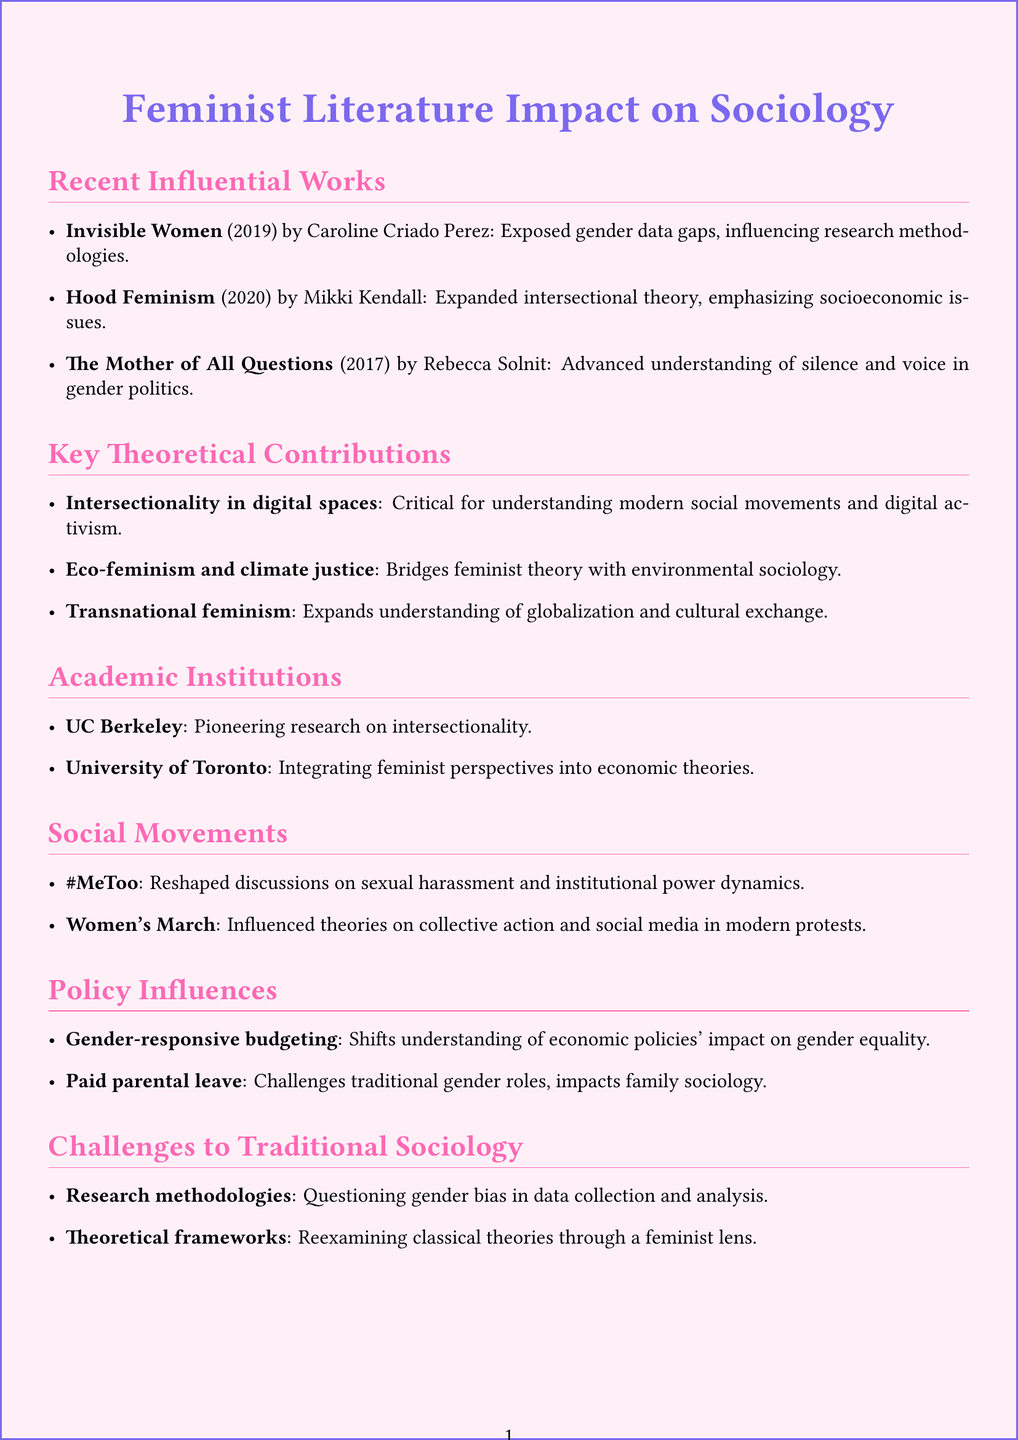What is the title of Mikki Kendall's book? Mikki Kendall's book title is listed under recent influential works in the document.
Answer: Hood Feminism: Notes from the Women That a Movement Forgot Who authored "Invisible Women"? The document specifies the author of "Invisible Women" in the recent influential works section.
Answer: Caroline Criado Perez In what year was "The Mother of All Questions" published? The year of publication for "The Mother of All Questions" is mentioned in the recent influential works section of the document.
Answer: 2017 What concept links feminist theory to environmental sociology? The document highlights a theoretical contribution that connects environmental issues to feminist theory.
Answer: Eco-feminism and climate justice Which social movement reshaped discussions on sexual harassment? The document identifies a movement that had a significant impact on discussions around sexual harassment in the social movements section.
Answer: #MeToo movement What academic institution is noted for research on intersectionality? The document mentions this institution's contribution in the academic institutions section.
Answer: Center for Intersectional Gender Studies, University of California, Berkeley What policy incorporates gender analysis in public financial management? The document defines a specific policy related to gender and economics.
Answer: Gender-responsive budgeting Which theoretical area examines classical theories through a feminist lens? The document discusses an area of challenges to traditional sociology focusing on theoretical frameworks.
Answer: Theoretical frameworks 